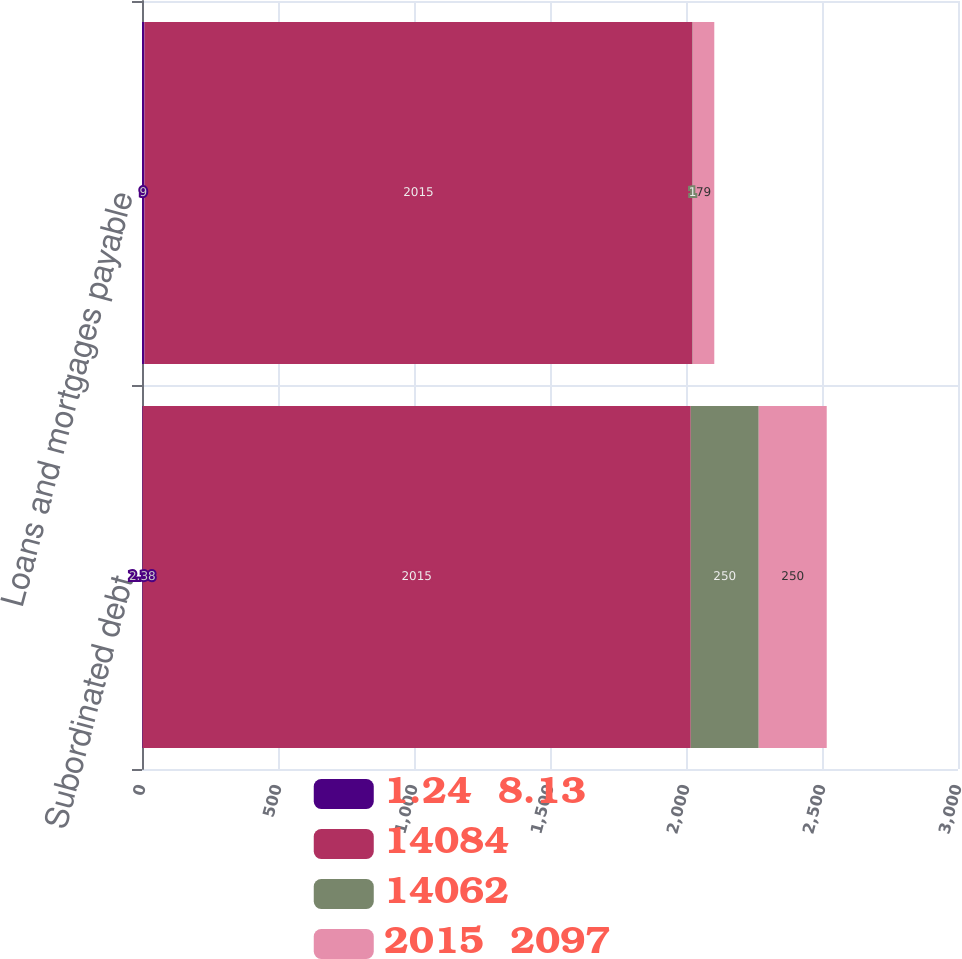<chart> <loc_0><loc_0><loc_500><loc_500><stacked_bar_chart><ecel><fcel>Subordinated debt<fcel>Loans and mortgages payable<nl><fcel>1.24  8.13<fcel>2.38<fcel>9<nl><fcel>14084<fcel>2015<fcel>2015<nl><fcel>14062<fcel>250<fcel>1<nl><fcel>2015  2097<fcel>250<fcel>79<nl></chart> 